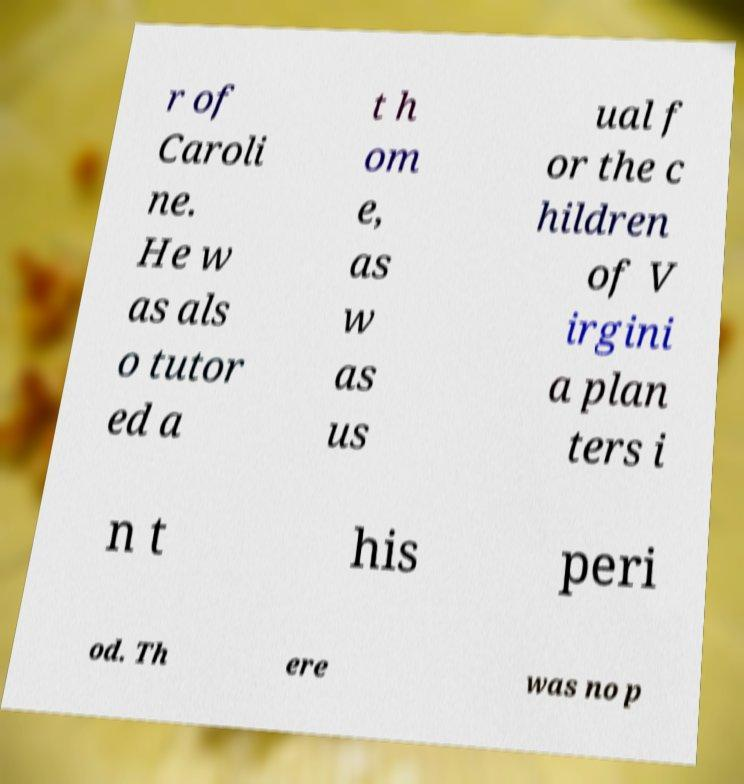Please read and relay the text visible in this image. What does it say? r of Caroli ne. He w as als o tutor ed a t h om e, as w as us ual f or the c hildren of V irgini a plan ters i n t his peri od. Th ere was no p 